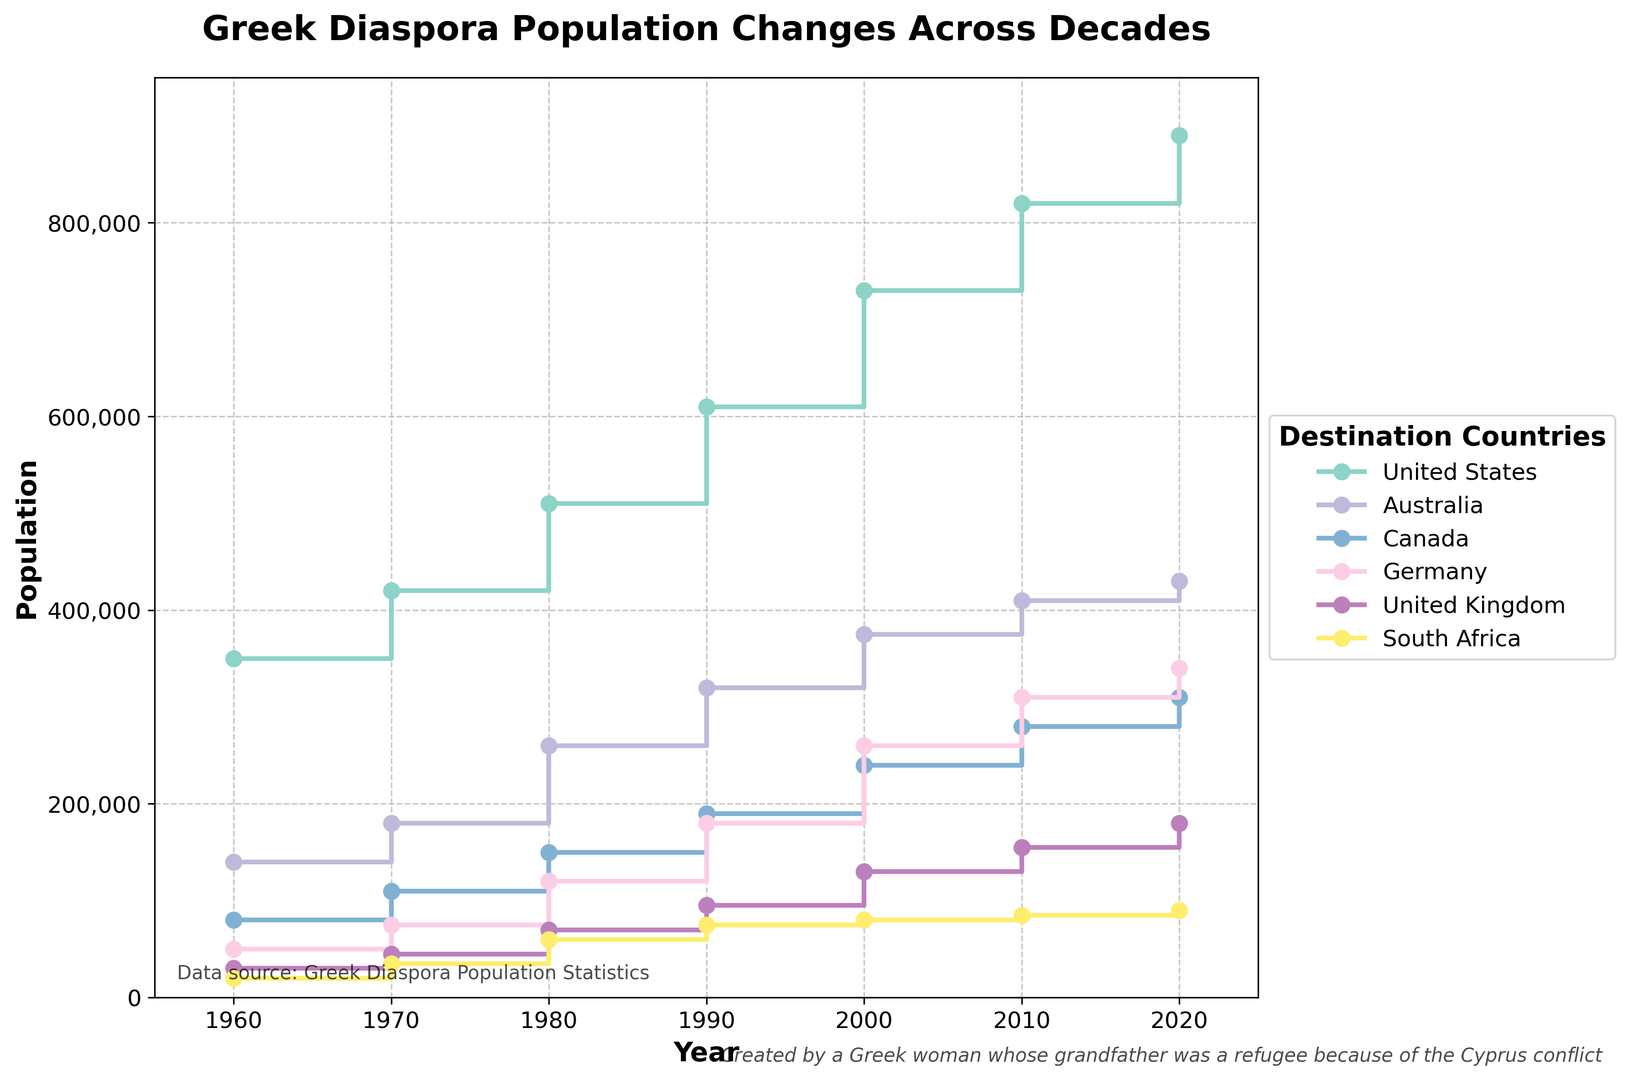Which country had the highest Greek diaspora population in 2020? According to the plot, the country with the highest Greek diaspora population in 2020 is identified by looking at the highest data point for that year. The United States shows the highest population.
Answer: United States How did the Greek diaspora population in Canada change from 1960 to 2020? The change in population for Canada from 1960 to 2020 can be found by looking at the values in these years and calculating the difference. In 1960, the population was 80,000, and by 2020, it increased to 310,000. The change is 310,000 - 80,000 = 230,000.
Answer: Increased by 230,000 Compare the populations of the Greek diaspora in Germany and South Africa in 2010. Which was higher, and by how much? Looking at the data points for 2010, the Greek diaspora population in Germany was 310,000, while in South Africa, it was 85,000. Subtract the population in South Africa from that in Germany, 310,000 - 85,000 = 225,000, to find the difference.
Answer: Germany by 225,000 What was the average Greek diaspora population in the United Kingdom over the decades shown? To find the average, sum the populations for each decade (30,000 in 1960, 45,000 in 1970, 70,000 in 1980, 95,000 in 1990, 130,000 in 2000, 155,000 in 2010, 180,000 in 2020), then divide by the number of decades (7). (30,000 + 45,000 + 70,000 + 95,000 + 130,000 + 155,000 + 180,000) / 7 = 100,714.
Answer: 100,714 Identify the country with the steepest increase in Greek diaspora population between 1980 and 1990, based on the visual plot. The steepest increase can be found by looking at the steepness of the lines between 1980 and 1990. The slope of the line for the United States is the most pronounced, indicating the highest increase. The increase for the USA was from 510,000 to 610,000, which is 100,000.
Answer: United States Which two countries had the closest Greek diaspora population in the year 2000? To find the two closest populations, compare the data points for each country in 2000: 730,000 (USA), 375,000 (Australia), 240,000 (Canada), 260,000 (Germany), 130,000 (UK), and 80,000 (South Africa). The two closest are Germany and Canada, with populations of 260,000 and 240,000, respectively. The difference is 260,000 - 240,000 = 20,000.
Answer: Germany and Canada What trends can be observed for the Greek diaspora in Australia from 1960 to 2020? Observing the values for Australia in each decade, the population increases steadily: 140,000 in 1960, 180,000 in 1970, 260,000 in 1980, 320,000 in 1990, 375,000 in 2000, 410,000 in 2010, and 430,000 in 2020. The trend indicates a continuous, generally increasing pattern over the years.
Answer: Continuous increase Among the countries listed, which had the smallest Greek diaspora population in every decade? By examining the heights of the lines across all decades, South Africa consistently shows the lowest population in each year compared to the other countries.
Answer: South Africa What percentage increase did the Greek diaspora in Germany experience from 1960 to 2020? The population in Germany in 1960 was 50,000 and increased to 340,000 by 2020. The percentage increase can be calculated as ((340,000 - 50,000) / 50,000) * 100 = 580%.
Answer: 580% Which country experienced the largest population increase between any two consecutive decades? To find the largest increase, compare the increases in population for all countries between consecutive decades. The largest increase is observed for the United States between 1990 (610,000) and 2000 (730,000), which is a change of 120,000.
Answer: United States 